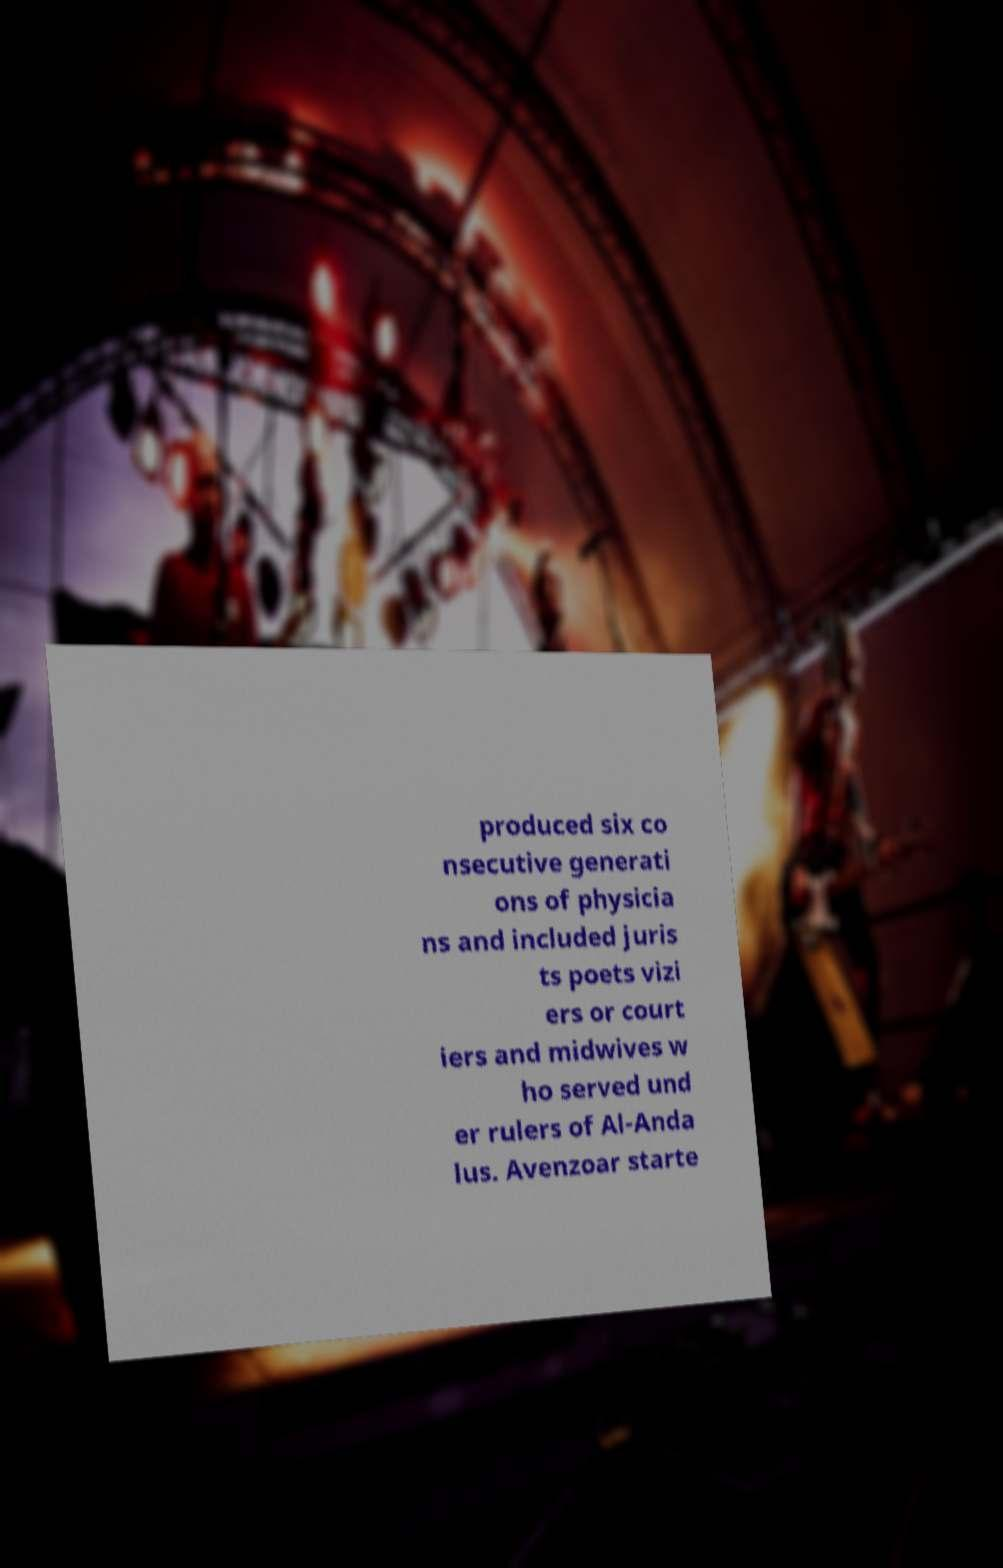I need the written content from this picture converted into text. Can you do that? produced six co nsecutive generati ons of physicia ns and included juris ts poets vizi ers or court iers and midwives w ho served und er rulers of Al-Anda lus. Avenzoar starte 